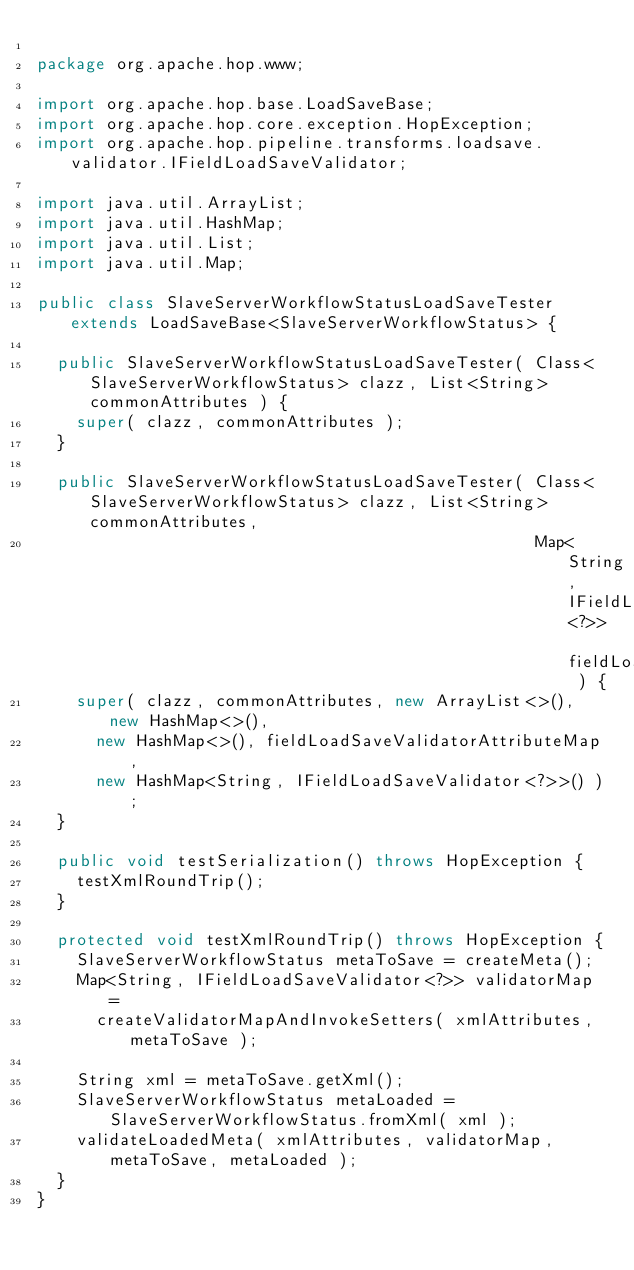Convert code to text. <code><loc_0><loc_0><loc_500><loc_500><_Java_>
package org.apache.hop.www;

import org.apache.hop.base.LoadSaveBase;
import org.apache.hop.core.exception.HopException;
import org.apache.hop.pipeline.transforms.loadsave.validator.IFieldLoadSaveValidator;

import java.util.ArrayList;
import java.util.HashMap;
import java.util.List;
import java.util.Map;

public class SlaveServerWorkflowStatusLoadSaveTester extends LoadSaveBase<SlaveServerWorkflowStatus> {

  public SlaveServerWorkflowStatusLoadSaveTester( Class<SlaveServerWorkflowStatus> clazz, List<String> commonAttributes ) {
    super( clazz, commonAttributes );
  }

  public SlaveServerWorkflowStatusLoadSaveTester( Class<SlaveServerWorkflowStatus> clazz, List<String> commonAttributes,
                                                  Map<String, IFieldLoadSaveValidator<?>> fieldLoadSaveValidatorAttributeMap ) {
    super( clazz, commonAttributes, new ArrayList<>(), new HashMap<>(),
      new HashMap<>(), fieldLoadSaveValidatorAttributeMap,
      new HashMap<String, IFieldLoadSaveValidator<?>>() );
  }

  public void testSerialization() throws HopException {
    testXmlRoundTrip();
  }

  protected void testXmlRoundTrip() throws HopException {
    SlaveServerWorkflowStatus metaToSave = createMeta();
    Map<String, IFieldLoadSaveValidator<?>> validatorMap =
      createValidatorMapAndInvokeSetters( xmlAttributes, metaToSave );

    String xml = metaToSave.getXml();
    SlaveServerWorkflowStatus metaLoaded = SlaveServerWorkflowStatus.fromXml( xml );
    validateLoadedMeta( xmlAttributes, validatorMap, metaToSave, metaLoaded );
  }
}
</code> 